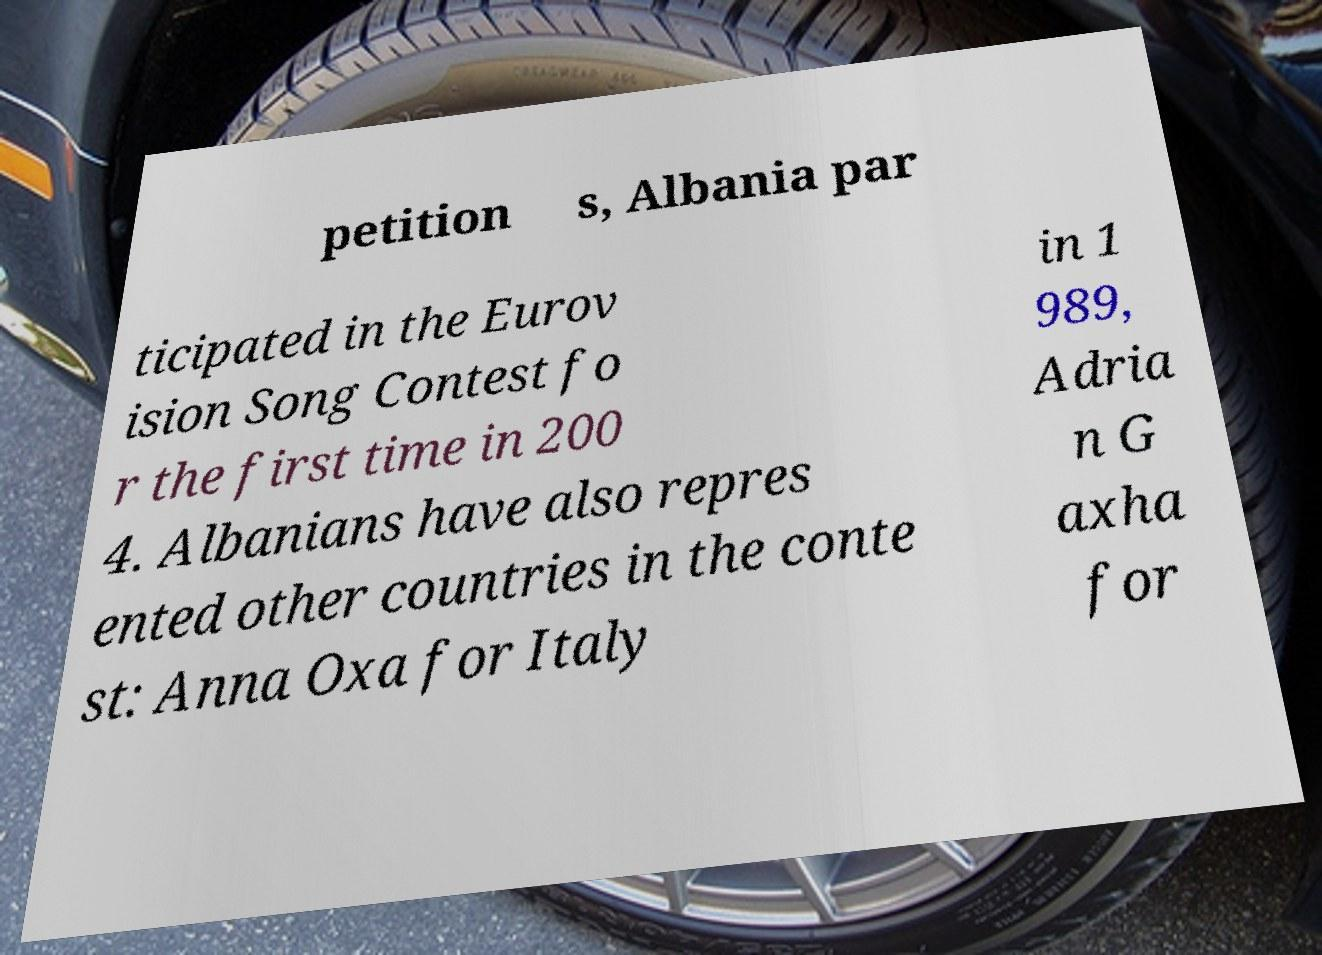I need the written content from this picture converted into text. Can you do that? petition s, Albania par ticipated in the Eurov ision Song Contest fo r the first time in 200 4. Albanians have also repres ented other countries in the conte st: Anna Oxa for Italy in 1 989, Adria n G axha for 